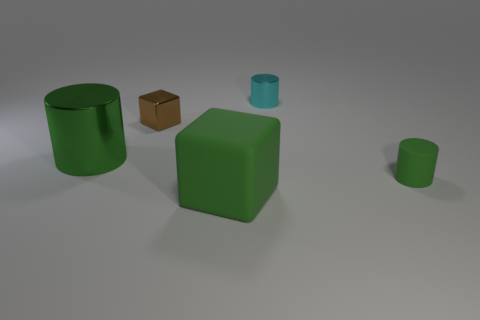Are the big green cylinder and the block behind the small green matte object made of the same material?
Offer a terse response. Yes. What is the color of the big thing that is in front of the small cylinder in front of the tiny cyan metallic cylinder to the right of the large metallic thing?
Keep it short and to the point. Green. Are there more green cylinders than tiny objects?
Make the answer very short. No. What number of things are on the left side of the green rubber cylinder and in front of the large shiny object?
Your answer should be very brief. 1. How many large objects are right of the large object that is in front of the large cylinder?
Offer a very short reply. 0. There is a green thing that is to the left of the big green rubber cube; does it have the same size as the cylinder to the right of the small cyan shiny thing?
Offer a very short reply. No. What number of big gray shiny cylinders are there?
Your response must be concise. 0. How many other big cubes are made of the same material as the green block?
Provide a succinct answer. 0. Are there the same number of large green metal objects behind the cyan metal object and small cyan shiny cylinders?
Ensure brevity in your answer.  No. There is a block that is the same color as the tiny matte cylinder; what is it made of?
Your answer should be very brief. Rubber. 